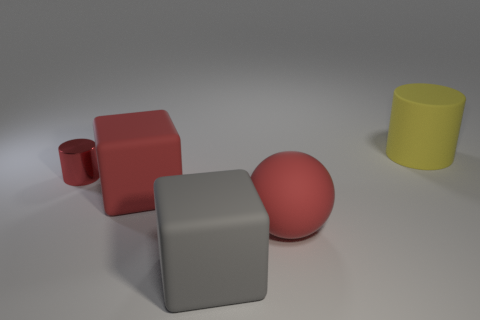There is another thing that is the same shape as the gray matte object; what size is it?
Your response must be concise. Large. Do the large cylinder and the sphere have the same color?
Your answer should be very brief. No. Are there any other things that have the same shape as the large gray thing?
Keep it short and to the point. Yes. Is there a tiny red cylinder in front of the red rubber object that is to the right of the large red cube?
Provide a succinct answer. No. What color is the large matte thing that is the same shape as the small red metal object?
Offer a terse response. Yellow. How many matte spheres are the same color as the small metallic thing?
Ensure brevity in your answer.  1. The large thing on the left side of the large matte thing in front of the large red thing that is right of the gray object is what color?
Offer a very short reply. Red. Are the big gray object and the large yellow cylinder made of the same material?
Make the answer very short. Yes. Is the shape of the gray rubber thing the same as the yellow rubber thing?
Ensure brevity in your answer.  No. Is the number of yellow rubber cylinders behind the large cylinder the same as the number of spheres that are in front of the large gray thing?
Provide a short and direct response. Yes. 